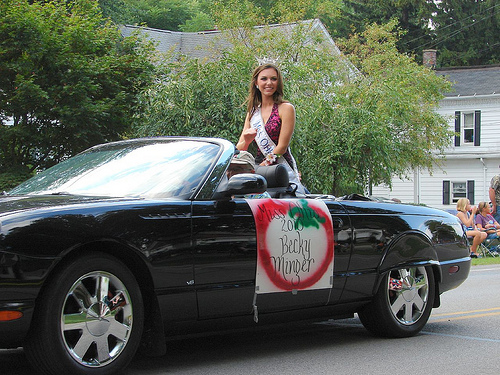<image>
Can you confirm if the sash is behind the car? No. The sash is not behind the car. From this viewpoint, the sash appears to be positioned elsewhere in the scene. Is the crown in front of the tree? Yes. The crown is positioned in front of the tree, appearing closer to the camera viewpoint. 